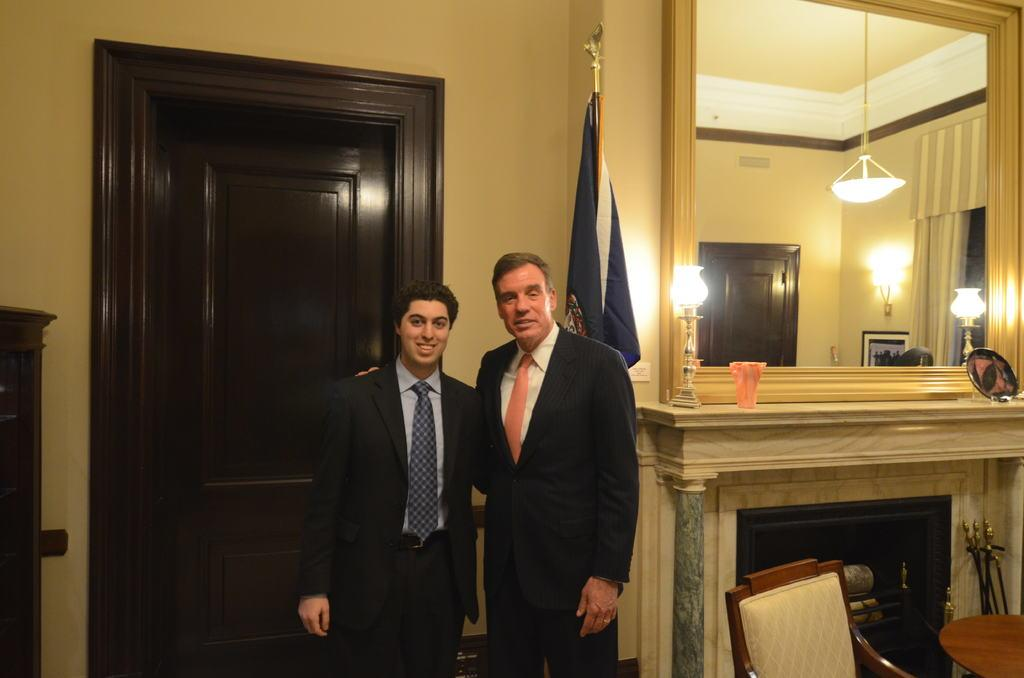How many people are in the image? There are two persons standing near the door. What objects can be seen in the background? There is a lamp, a flag, a mirror, a curtain, a frame, a chair, and a table in the background. What type of amusement can be seen in the image? There is no amusement present in the image; it features two persons standing near the door and various objects in the background. What is the relation between the two persons in the image? The provided facts do not give any information about the relationship between the two persons in the image. 